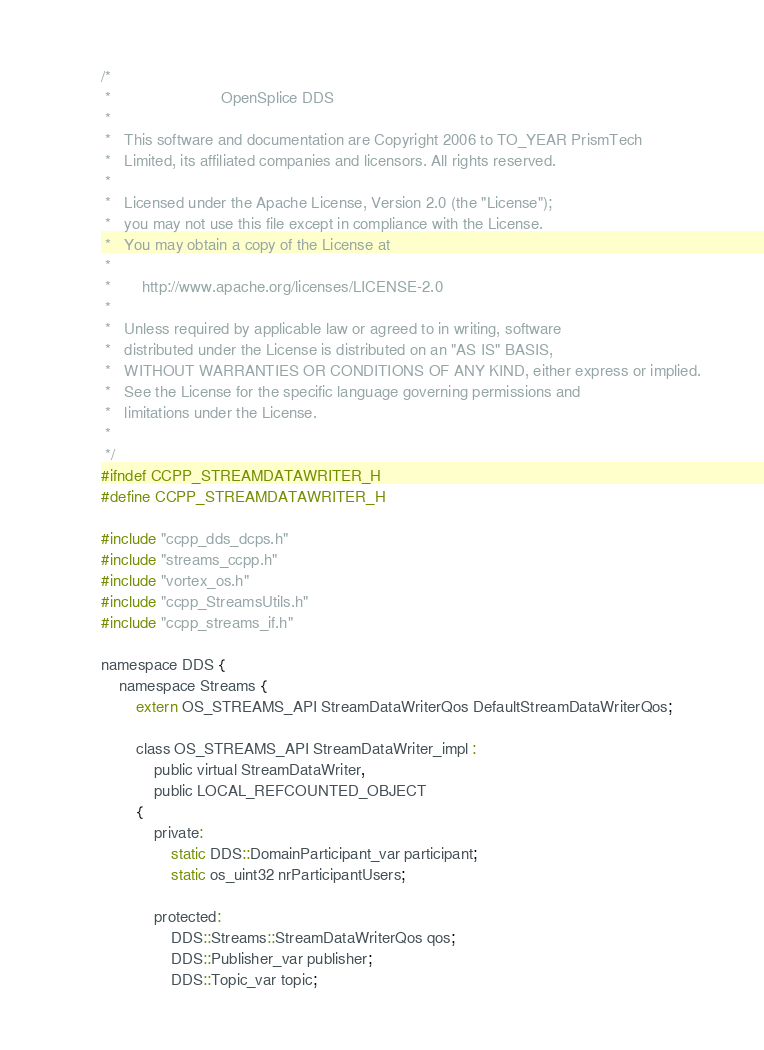<code> <loc_0><loc_0><loc_500><loc_500><_C_>/*
 *                         OpenSplice DDS
 *
 *   This software and documentation are Copyright 2006 to TO_YEAR PrismTech
 *   Limited, its affiliated companies and licensors. All rights reserved.
 *
 *   Licensed under the Apache License, Version 2.0 (the "License");
 *   you may not use this file except in compliance with the License.
 *   You may obtain a copy of the License at
 *
 *       http://www.apache.org/licenses/LICENSE-2.0
 *
 *   Unless required by applicable law or agreed to in writing, software
 *   distributed under the License is distributed on an "AS IS" BASIS,
 *   WITHOUT WARRANTIES OR CONDITIONS OF ANY KIND, either express or implied.
 *   See the License for the specific language governing permissions and
 *   limitations under the License.
 *
 */
#ifndef CCPP_STREAMDATAWRITER_H
#define CCPP_STREAMDATAWRITER_H

#include "ccpp_dds_dcps.h"
#include "streams_ccpp.h"
#include "vortex_os.h"
#include "ccpp_StreamsUtils.h"
#include "ccpp_streams_if.h"

namespace DDS {
    namespace Streams {
        extern OS_STREAMS_API StreamDataWriterQos DefaultStreamDataWriterQos;

        class OS_STREAMS_API StreamDataWriter_impl :
            public virtual StreamDataWriter,
            public LOCAL_REFCOUNTED_OBJECT
        {
            private:
                static DDS::DomainParticipant_var participant;
                static os_uint32 nrParticipantUsers;

            protected:
                DDS::Streams::StreamDataWriterQos qos;
                DDS::Publisher_var publisher;
                DDS::Topic_var topic;
</code> 